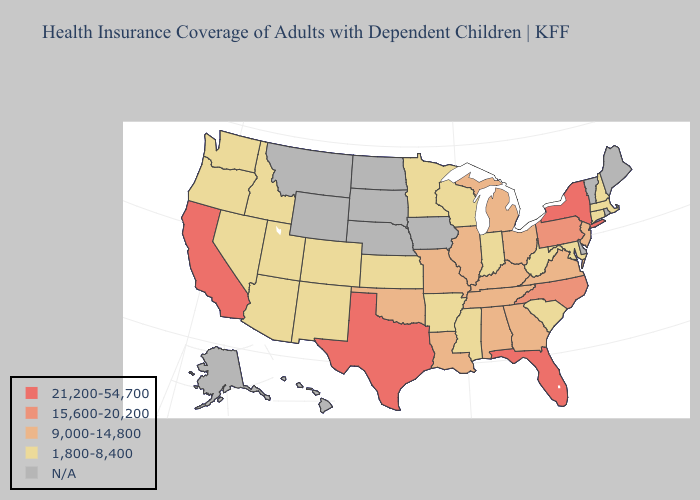Among the states that border Tennessee , does North Carolina have the highest value?
Be succinct. Yes. Does Pennsylvania have the highest value in the USA?
Give a very brief answer. No. Name the states that have a value in the range N/A?
Answer briefly. Alaska, Delaware, Hawaii, Iowa, Maine, Montana, Nebraska, North Dakota, Rhode Island, South Dakota, Vermont, Wyoming. What is the value of New York?
Give a very brief answer. 21,200-54,700. What is the lowest value in the Northeast?
Answer briefly. 1,800-8,400. Which states have the highest value in the USA?
Keep it brief. California, Florida, New York, Texas. Name the states that have a value in the range 9,000-14,800?
Quick response, please. Alabama, Georgia, Illinois, Kentucky, Louisiana, Michigan, Missouri, New Jersey, Ohio, Oklahoma, Tennessee, Virginia. What is the value of Florida?
Write a very short answer. 21,200-54,700. Name the states that have a value in the range 21,200-54,700?
Answer briefly. California, Florida, New York, Texas. Does Pennsylvania have the lowest value in the USA?
Quick response, please. No. Does Massachusetts have the lowest value in the USA?
Quick response, please. Yes. What is the highest value in the Northeast ?
Write a very short answer. 21,200-54,700. What is the highest value in the USA?
Quick response, please. 21,200-54,700. What is the lowest value in states that border New Hampshire?
Quick response, please. 1,800-8,400. Name the states that have a value in the range 15,600-20,200?
Answer briefly. North Carolina, Pennsylvania. 